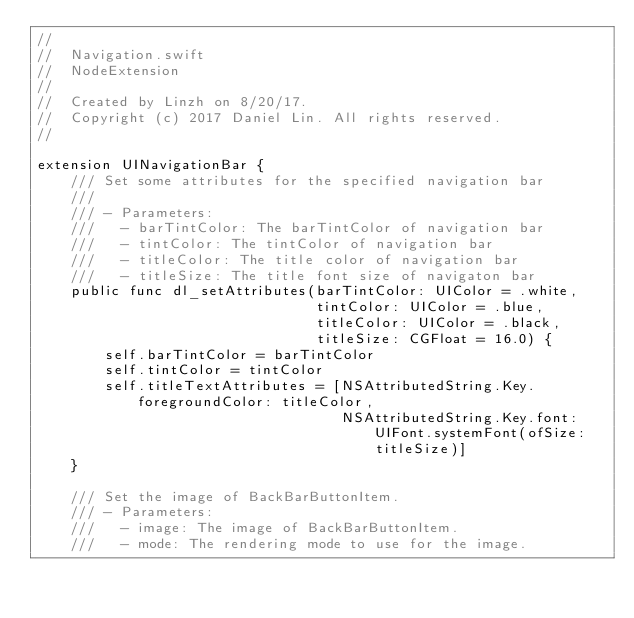Convert code to text. <code><loc_0><loc_0><loc_500><loc_500><_Swift_>//
//  Navigation.swift
//  NodeExtension
//
//  Created by Linzh on 8/20/17.
//  Copyright (c) 2017 Daniel Lin. All rights reserved.
//

extension UINavigationBar {
    /// Set some attributes for the specified navigation bar
    ///
    /// - Parameters:
    ///   - barTintColor: The barTintColor of navigation bar
    ///   - tintColor: The tintColor of navigation bar
    ///   - titleColor: The title color of navigation bar
    ///   - titleSize: The title font size of navigaton bar
    public func dl_setAttributes(barTintColor: UIColor = .white,
                                 tintColor: UIColor = .blue,
                                 titleColor: UIColor = .black,
                                 titleSize: CGFloat = 16.0) {
        self.barTintColor = barTintColor
        self.tintColor = tintColor
        self.titleTextAttributes = [NSAttributedString.Key.foregroundColor: titleColor,
                                    NSAttributedString.Key.font: UIFont.systemFont(ofSize: titleSize)]
    }

    /// Set the image of BackBarButtonItem.
    /// - Parameters:
    ///   - image: The image of BackBarButtonItem.
    ///   - mode: The rendering mode to use for the image.</code> 